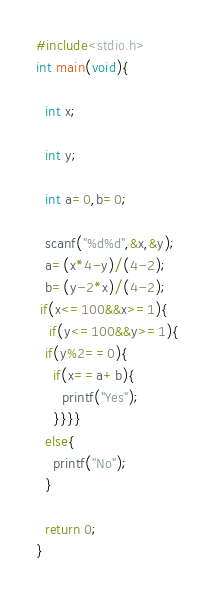Convert code to text. <code><loc_0><loc_0><loc_500><loc_500><_C_>#include<stdio.h>
int main(void){
 
  int x;
    
  int y; 
   
  int a=0,b=0;
  
  scanf("%d%d",&x,&y);
  a=(x*4-y)/(4-2);
  b=(y-2*x)/(4-2);
 if(x<=100&&x>=1){
   if(y<=100&&y>=1){
  if(y%2==0){
    if(x==a+b){
      printf("Yes");
    }}}}
  else{
    printf("No");
  }
  
  return 0;
}</code> 